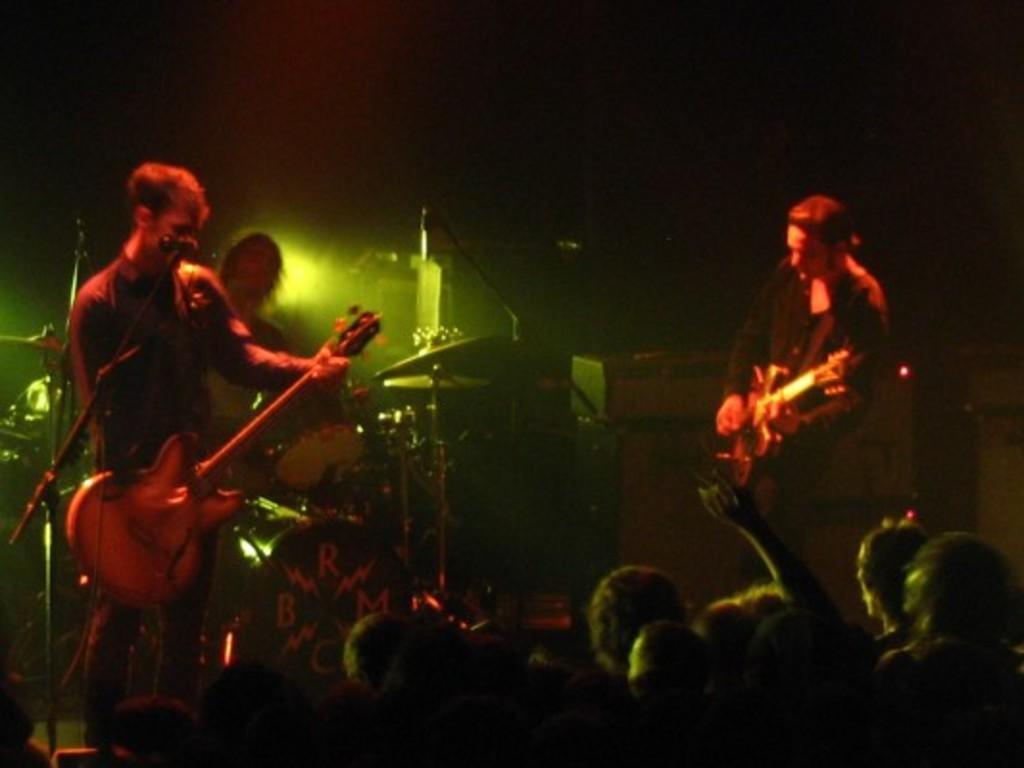Please provide a concise description of this image. In this image we can see a three people performing on a musical stage. They are playing a guitar, playing a snare drum and singing on a microphone. Here we can see a few audience who are watching these people. 